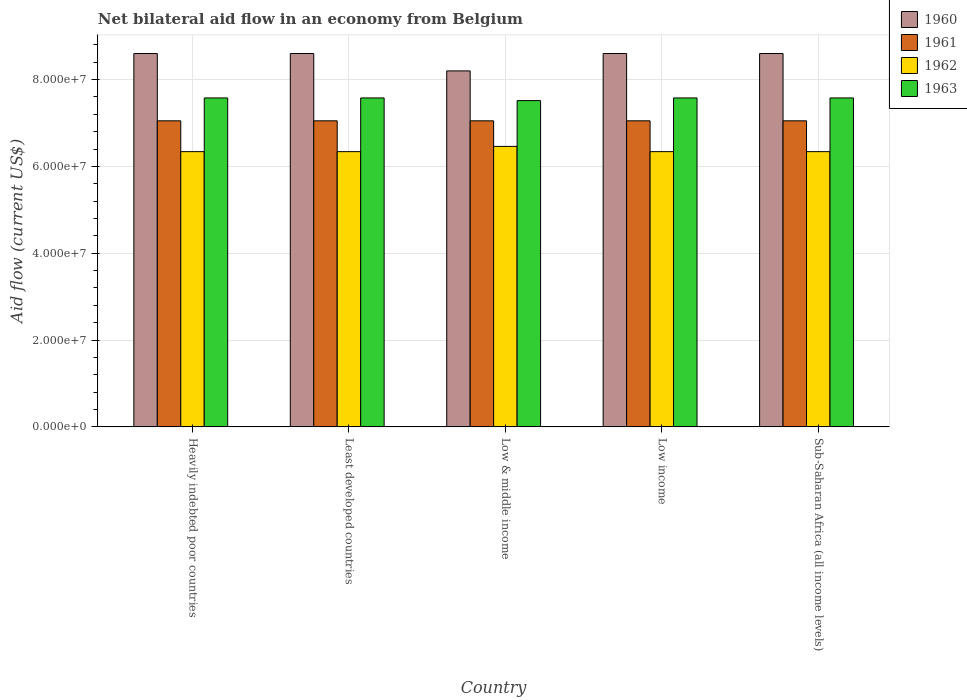How many groups of bars are there?
Keep it short and to the point. 5. Are the number of bars per tick equal to the number of legend labels?
Provide a succinct answer. Yes. How many bars are there on the 3rd tick from the left?
Make the answer very short. 4. How many bars are there on the 1st tick from the right?
Your answer should be very brief. 4. What is the label of the 5th group of bars from the left?
Provide a succinct answer. Sub-Saharan Africa (all income levels). In how many cases, is the number of bars for a given country not equal to the number of legend labels?
Offer a terse response. 0. What is the net bilateral aid flow in 1960 in Low & middle income?
Provide a succinct answer. 8.20e+07. Across all countries, what is the maximum net bilateral aid flow in 1960?
Ensure brevity in your answer.  8.60e+07. Across all countries, what is the minimum net bilateral aid flow in 1961?
Your answer should be compact. 7.05e+07. In which country was the net bilateral aid flow in 1963 maximum?
Offer a terse response. Heavily indebted poor countries. In which country was the net bilateral aid flow in 1962 minimum?
Make the answer very short. Heavily indebted poor countries. What is the total net bilateral aid flow in 1960 in the graph?
Your answer should be very brief. 4.26e+08. What is the difference between the net bilateral aid flow in 1963 in Sub-Saharan Africa (all income levels) and the net bilateral aid flow in 1962 in Least developed countries?
Provide a short and direct response. 1.24e+07. What is the average net bilateral aid flow in 1963 per country?
Your answer should be compact. 7.56e+07. What is the difference between the net bilateral aid flow of/in 1962 and net bilateral aid flow of/in 1960 in Low & middle income?
Keep it short and to the point. -1.74e+07. In how many countries, is the net bilateral aid flow in 1960 greater than 36000000 US$?
Offer a very short reply. 5. What is the ratio of the net bilateral aid flow in 1963 in Low income to that in Sub-Saharan Africa (all income levels)?
Your answer should be very brief. 1. Is the difference between the net bilateral aid flow in 1962 in Heavily indebted poor countries and Sub-Saharan Africa (all income levels) greater than the difference between the net bilateral aid flow in 1960 in Heavily indebted poor countries and Sub-Saharan Africa (all income levels)?
Offer a very short reply. No. What is the difference between the highest and the second highest net bilateral aid flow in 1962?
Ensure brevity in your answer.  1.21e+06. What is the difference between the highest and the lowest net bilateral aid flow in 1961?
Your response must be concise. 0. Is the sum of the net bilateral aid flow in 1963 in Heavily indebted poor countries and Low income greater than the maximum net bilateral aid flow in 1960 across all countries?
Make the answer very short. Yes. Is it the case that in every country, the sum of the net bilateral aid flow in 1960 and net bilateral aid flow in 1963 is greater than the sum of net bilateral aid flow in 1961 and net bilateral aid flow in 1962?
Provide a short and direct response. No. What is the difference between two consecutive major ticks on the Y-axis?
Your answer should be very brief. 2.00e+07. Are the values on the major ticks of Y-axis written in scientific E-notation?
Your response must be concise. Yes. Does the graph contain grids?
Make the answer very short. Yes. Where does the legend appear in the graph?
Give a very brief answer. Top right. How many legend labels are there?
Your answer should be compact. 4. How are the legend labels stacked?
Offer a very short reply. Vertical. What is the title of the graph?
Ensure brevity in your answer.  Net bilateral aid flow in an economy from Belgium. Does "2011" appear as one of the legend labels in the graph?
Your response must be concise. No. What is the label or title of the Y-axis?
Your answer should be compact. Aid flow (current US$). What is the Aid flow (current US$) in 1960 in Heavily indebted poor countries?
Ensure brevity in your answer.  8.60e+07. What is the Aid flow (current US$) of 1961 in Heavily indebted poor countries?
Your answer should be very brief. 7.05e+07. What is the Aid flow (current US$) of 1962 in Heavily indebted poor countries?
Offer a terse response. 6.34e+07. What is the Aid flow (current US$) in 1963 in Heavily indebted poor countries?
Offer a very short reply. 7.58e+07. What is the Aid flow (current US$) of 1960 in Least developed countries?
Your response must be concise. 8.60e+07. What is the Aid flow (current US$) of 1961 in Least developed countries?
Provide a short and direct response. 7.05e+07. What is the Aid flow (current US$) in 1962 in Least developed countries?
Keep it short and to the point. 6.34e+07. What is the Aid flow (current US$) in 1963 in Least developed countries?
Offer a very short reply. 7.58e+07. What is the Aid flow (current US$) in 1960 in Low & middle income?
Offer a very short reply. 8.20e+07. What is the Aid flow (current US$) of 1961 in Low & middle income?
Provide a short and direct response. 7.05e+07. What is the Aid flow (current US$) in 1962 in Low & middle income?
Your answer should be compact. 6.46e+07. What is the Aid flow (current US$) in 1963 in Low & middle income?
Provide a short and direct response. 7.52e+07. What is the Aid flow (current US$) of 1960 in Low income?
Your answer should be very brief. 8.60e+07. What is the Aid flow (current US$) of 1961 in Low income?
Give a very brief answer. 7.05e+07. What is the Aid flow (current US$) in 1962 in Low income?
Keep it short and to the point. 6.34e+07. What is the Aid flow (current US$) of 1963 in Low income?
Provide a short and direct response. 7.58e+07. What is the Aid flow (current US$) of 1960 in Sub-Saharan Africa (all income levels)?
Your answer should be compact. 8.60e+07. What is the Aid flow (current US$) in 1961 in Sub-Saharan Africa (all income levels)?
Offer a very short reply. 7.05e+07. What is the Aid flow (current US$) in 1962 in Sub-Saharan Africa (all income levels)?
Offer a terse response. 6.34e+07. What is the Aid flow (current US$) of 1963 in Sub-Saharan Africa (all income levels)?
Give a very brief answer. 7.58e+07. Across all countries, what is the maximum Aid flow (current US$) in 1960?
Ensure brevity in your answer.  8.60e+07. Across all countries, what is the maximum Aid flow (current US$) of 1961?
Provide a succinct answer. 7.05e+07. Across all countries, what is the maximum Aid flow (current US$) of 1962?
Ensure brevity in your answer.  6.46e+07. Across all countries, what is the maximum Aid flow (current US$) in 1963?
Your answer should be very brief. 7.58e+07. Across all countries, what is the minimum Aid flow (current US$) in 1960?
Make the answer very short. 8.20e+07. Across all countries, what is the minimum Aid flow (current US$) of 1961?
Provide a succinct answer. 7.05e+07. Across all countries, what is the minimum Aid flow (current US$) of 1962?
Make the answer very short. 6.34e+07. Across all countries, what is the minimum Aid flow (current US$) of 1963?
Keep it short and to the point. 7.52e+07. What is the total Aid flow (current US$) in 1960 in the graph?
Give a very brief answer. 4.26e+08. What is the total Aid flow (current US$) in 1961 in the graph?
Make the answer very short. 3.52e+08. What is the total Aid flow (current US$) in 1962 in the graph?
Your answer should be compact. 3.18e+08. What is the total Aid flow (current US$) in 1963 in the graph?
Ensure brevity in your answer.  3.78e+08. What is the difference between the Aid flow (current US$) of 1961 in Heavily indebted poor countries and that in Low & middle income?
Your response must be concise. 0. What is the difference between the Aid flow (current US$) in 1962 in Heavily indebted poor countries and that in Low & middle income?
Ensure brevity in your answer.  -1.21e+06. What is the difference between the Aid flow (current US$) of 1963 in Heavily indebted poor countries and that in Low & middle income?
Offer a terse response. 6.10e+05. What is the difference between the Aid flow (current US$) in 1960 in Heavily indebted poor countries and that in Low income?
Make the answer very short. 0. What is the difference between the Aid flow (current US$) in 1961 in Heavily indebted poor countries and that in Low income?
Give a very brief answer. 0. What is the difference between the Aid flow (current US$) of 1963 in Heavily indebted poor countries and that in Low income?
Your answer should be very brief. 0. What is the difference between the Aid flow (current US$) in 1961 in Heavily indebted poor countries and that in Sub-Saharan Africa (all income levels)?
Your answer should be very brief. 0. What is the difference between the Aid flow (current US$) in 1962 in Heavily indebted poor countries and that in Sub-Saharan Africa (all income levels)?
Ensure brevity in your answer.  0. What is the difference between the Aid flow (current US$) in 1963 in Heavily indebted poor countries and that in Sub-Saharan Africa (all income levels)?
Give a very brief answer. 0. What is the difference between the Aid flow (current US$) in 1961 in Least developed countries and that in Low & middle income?
Offer a very short reply. 0. What is the difference between the Aid flow (current US$) of 1962 in Least developed countries and that in Low & middle income?
Offer a very short reply. -1.21e+06. What is the difference between the Aid flow (current US$) in 1963 in Least developed countries and that in Low & middle income?
Your response must be concise. 6.10e+05. What is the difference between the Aid flow (current US$) in 1960 in Least developed countries and that in Low income?
Provide a succinct answer. 0. What is the difference between the Aid flow (current US$) of 1962 in Least developed countries and that in Low income?
Offer a terse response. 0. What is the difference between the Aid flow (current US$) in 1960 in Least developed countries and that in Sub-Saharan Africa (all income levels)?
Your answer should be very brief. 0. What is the difference between the Aid flow (current US$) of 1962 in Least developed countries and that in Sub-Saharan Africa (all income levels)?
Offer a terse response. 0. What is the difference between the Aid flow (current US$) of 1963 in Least developed countries and that in Sub-Saharan Africa (all income levels)?
Keep it short and to the point. 0. What is the difference between the Aid flow (current US$) of 1962 in Low & middle income and that in Low income?
Ensure brevity in your answer.  1.21e+06. What is the difference between the Aid flow (current US$) in 1963 in Low & middle income and that in Low income?
Ensure brevity in your answer.  -6.10e+05. What is the difference between the Aid flow (current US$) in 1961 in Low & middle income and that in Sub-Saharan Africa (all income levels)?
Give a very brief answer. 0. What is the difference between the Aid flow (current US$) in 1962 in Low & middle income and that in Sub-Saharan Africa (all income levels)?
Provide a succinct answer. 1.21e+06. What is the difference between the Aid flow (current US$) in 1963 in Low & middle income and that in Sub-Saharan Africa (all income levels)?
Your answer should be compact. -6.10e+05. What is the difference between the Aid flow (current US$) in 1963 in Low income and that in Sub-Saharan Africa (all income levels)?
Ensure brevity in your answer.  0. What is the difference between the Aid flow (current US$) of 1960 in Heavily indebted poor countries and the Aid flow (current US$) of 1961 in Least developed countries?
Offer a very short reply. 1.55e+07. What is the difference between the Aid flow (current US$) in 1960 in Heavily indebted poor countries and the Aid flow (current US$) in 1962 in Least developed countries?
Your answer should be very brief. 2.26e+07. What is the difference between the Aid flow (current US$) in 1960 in Heavily indebted poor countries and the Aid flow (current US$) in 1963 in Least developed countries?
Make the answer very short. 1.02e+07. What is the difference between the Aid flow (current US$) in 1961 in Heavily indebted poor countries and the Aid flow (current US$) in 1962 in Least developed countries?
Offer a terse response. 7.10e+06. What is the difference between the Aid flow (current US$) in 1961 in Heavily indebted poor countries and the Aid flow (current US$) in 1963 in Least developed countries?
Give a very brief answer. -5.27e+06. What is the difference between the Aid flow (current US$) in 1962 in Heavily indebted poor countries and the Aid flow (current US$) in 1963 in Least developed countries?
Ensure brevity in your answer.  -1.24e+07. What is the difference between the Aid flow (current US$) in 1960 in Heavily indebted poor countries and the Aid flow (current US$) in 1961 in Low & middle income?
Offer a very short reply. 1.55e+07. What is the difference between the Aid flow (current US$) of 1960 in Heavily indebted poor countries and the Aid flow (current US$) of 1962 in Low & middle income?
Ensure brevity in your answer.  2.14e+07. What is the difference between the Aid flow (current US$) of 1960 in Heavily indebted poor countries and the Aid flow (current US$) of 1963 in Low & middle income?
Keep it short and to the point. 1.08e+07. What is the difference between the Aid flow (current US$) of 1961 in Heavily indebted poor countries and the Aid flow (current US$) of 1962 in Low & middle income?
Offer a very short reply. 5.89e+06. What is the difference between the Aid flow (current US$) of 1961 in Heavily indebted poor countries and the Aid flow (current US$) of 1963 in Low & middle income?
Your response must be concise. -4.66e+06. What is the difference between the Aid flow (current US$) in 1962 in Heavily indebted poor countries and the Aid flow (current US$) in 1963 in Low & middle income?
Your answer should be very brief. -1.18e+07. What is the difference between the Aid flow (current US$) of 1960 in Heavily indebted poor countries and the Aid flow (current US$) of 1961 in Low income?
Offer a terse response. 1.55e+07. What is the difference between the Aid flow (current US$) of 1960 in Heavily indebted poor countries and the Aid flow (current US$) of 1962 in Low income?
Offer a very short reply. 2.26e+07. What is the difference between the Aid flow (current US$) of 1960 in Heavily indebted poor countries and the Aid flow (current US$) of 1963 in Low income?
Offer a terse response. 1.02e+07. What is the difference between the Aid flow (current US$) of 1961 in Heavily indebted poor countries and the Aid flow (current US$) of 1962 in Low income?
Keep it short and to the point. 7.10e+06. What is the difference between the Aid flow (current US$) in 1961 in Heavily indebted poor countries and the Aid flow (current US$) in 1963 in Low income?
Ensure brevity in your answer.  -5.27e+06. What is the difference between the Aid flow (current US$) of 1962 in Heavily indebted poor countries and the Aid flow (current US$) of 1963 in Low income?
Offer a very short reply. -1.24e+07. What is the difference between the Aid flow (current US$) of 1960 in Heavily indebted poor countries and the Aid flow (current US$) of 1961 in Sub-Saharan Africa (all income levels)?
Provide a succinct answer. 1.55e+07. What is the difference between the Aid flow (current US$) in 1960 in Heavily indebted poor countries and the Aid flow (current US$) in 1962 in Sub-Saharan Africa (all income levels)?
Provide a succinct answer. 2.26e+07. What is the difference between the Aid flow (current US$) in 1960 in Heavily indebted poor countries and the Aid flow (current US$) in 1963 in Sub-Saharan Africa (all income levels)?
Give a very brief answer. 1.02e+07. What is the difference between the Aid flow (current US$) in 1961 in Heavily indebted poor countries and the Aid flow (current US$) in 1962 in Sub-Saharan Africa (all income levels)?
Give a very brief answer. 7.10e+06. What is the difference between the Aid flow (current US$) in 1961 in Heavily indebted poor countries and the Aid flow (current US$) in 1963 in Sub-Saharan Africa (all income levels)?
Make the answer very short. -5.27e+06. What is the difference between the Aid flow (current US$) in 1962 in Heavily indebted poor countries and the Aid flow (current US$) in 1963 in Sub-Saharan Africa (all income levels)?
Offer a very short reply. -1.24e+07. What is the difference between the Aid flow (current US$) of 1960 in Least developed countries and the Aid flow (current US$) of 1961 in Low & middle income?
Keep it short and to the point. 1.55e+07. What is the difference between the Aid flow (current US$) in 1960 in Least developed countries and the Aid flow (current US$) in 1962 in Low & middle income?
Your response must be concise. 2.14e+07. What is the difference between the Aid flow (current US$) in 1960 in Least developed countries and the Aid flow (current US$) in 1963 in Low & middle income?
Give a very brief answer. 1.08e+07. What is the difference between the Aid flow (current US$) of 1961 in Least developed countries and the Aid flow (current US$) of 1962 in Low & middle income?
Ensure brevity in your answer.  5.89e+06. What is the difference between the Aid flow (current US$) in 1961 in Least developed countries and the Aid flow (current US$) in 1963 in Low & middle income?
Keep it short and to the point. -4.66e+06. What is the difference between the Aid flow (current US$) in 1962 in Least developed countries and the Aid flow (current US$) in 1963 in Low & middle income?
Your answer should be compact. -1.18e+07. What is the difference between the Aid flow (current US$) of 1960 in Least developed countries and the Aid flow (current US$) of 1961 in Low income?
Provide a short and direct response. 1.55e+07. What is the difference between the Aid flow (current US$) of 1960 in Least developed countries and the Aid flow (current US$) of 1962 in Low income?
Offer a very short reply. 2.26e+07. What is the difference between the Aid flow (current US$) of 1960 in Least developed countries and the Aid flow (current US$) of 1963 in Low income?
Ensure brevity in your answer.  1.02e+07. What is the difference between the Aid flow (current US$) of 1961 in Least developed countries and the Aid flow (current US$) of 1962 in Low income?
Give a very brief answer. 7.10e+06. What is the difference between the Aid flow (current US$) in 1961 in Least developed countries and the Aid flow (current US$) in 1963 in Low income?
Offer a very short reply. -5.27e+06. What is the difference between the Aid flow (current US$) of 1962 in Least developed countries and the Aid flow (current US$) of 1963 in Low income?
Ensure brevity in your answer.  -1.24e+07. What is the difference between the Aid flow (current US$) of 1960 in Least developed countries and the Aid flow (current US$) of 1961 in Sub-Saharan Africa (all income levels)?
Your response must be concise. 1.55e+07. What is the difference between the Aid flow (current US$) of 1960 in Least developed countries and the Aid flow (current US$) of 1962 in Sub-Saharan Africa (all income levels)?
Make the answer very short. 2.26e+07. What is the difference between the Aid flow (current US$) in 1960 in Least developed countries and the Aid flow (current US$) in 1963 in Sub-Saharan Africa (all income levels)?
Your answer should be very brief. 1.02e+07. What is the difference between the Aid flow (current US$) in 1961 in Least developed countries and the Aid flow (current US$) in 1962 in Sub-Saharan Africa (all income levels)?
Make the answer very short. 7.10e+06. What is the difference between the Aid flow (current US$) of 1961 in Least developed countries and the Aid flow (current US$) of 1963 in Sub-Saharan Africa (all income levels)?
Ensure brevity in your answer.  -5.27e+06. What is the difference between the Aid flow (current US$) of 1962 in Least developed countries and the Aid flow (current US$) of 1963 in Sub-Saharan Africa (all income levels)?
Offer a terse response. -1.24e+07. What is the difference between the Aid flow (current US$) in 1960 in Low & middle income and the Aid flow (current US$) in 1961 in Low income?
Offer a terse response. 1.15e+07. What is the difference between the Aid flow (current US$) in 1960 in Low & middle income and the Aid flow (current US$) in 1962 in Low income?
Provide a succinct answer. 1.86e+07. What is the difference between the Aid flow (current US$) of 1960 in Low & middle income and the Aid flow (current US$) of 1963 in Low income?
Ensure brevity in your answer.  6.23e+06. What is the difference between the Aid flow (current US$) of 1961 in Low & middle income and the Aid flow (current US$) of 1962 in Low income?
Offer a terse response. 7.10e+06. What is the difference between the Aid flow (current US$) in 1961 in Low & middle income and the Aid flow (current US$) in 1963 in Low income?
Keep it short and to the point. -5.27e+06. What is the difference between the Aid flow (current US$) in 1962 in Low & middle income and the Aid flow (current US$) in 1963 in Low income?
Make the answer very short. -1.12e+07. What is the difference between the Aid flow (current US$) in 1960 in Low & middle income and the Aid flow (current US$) in 1961 in Sub-Saharan Africa (all income levels)?
Provide a succinct answer. 1.15e+07. What is the difference between the Aid flow (current US$) in 1960 in Low & middle income and the Aid flow (current US$) in 1962 in Sub-Saharan Africa (all income levels)?
Offer a very short reply. 1.86e+07. What is the difference between the Aid flow (current US$) in 1960 in Low & middle income and the Aid flow (current US$) in 1963 in Sub-Saharan Africa (all income levels)?
Offer a terse response. 6.23e+06. What is the difference between the Aid flow (current US$) of 1961 in Low & middle income and the Aid flow (current US$) of 1962 in Sub-Saharan Africa (all income levels)?
Make the answer very short. 7.10e+06. What is the difference between the Aid flow (current US$) of 1961 in Low & middle income and the Aid flow (current US$) of 1963 in Sub-Saharan Africa (all income levels)?
Keep it short and to the point. -5.27e+06. What is the difference between the Aid flow (current US$) in 1962 in Low & middle income and the Aid flow (current US$) in 1963 in Sub-Saharan Africa (all income levels)?
Offer a terse response. -1.12e+07. What is the difference between the Aid flow (current US$) in 1960 in Low income and the Aid flow (current US$) in 1961 in Sub-Saharan Africa (all income levels)?
Provide a succinct answer. 1.55e+07. What is the difference between the Aid flow (current US$) of 1960 in Low income and the Aid flow (current US$) of 1962 in Sub-Saharan Africa (all income levels)?
Ensure brevity in your answer.  2.26e+07. What is the difference between the Aid flow (current US$) of 1960 in Low income and the Aid flow (current US$) of 1963 in Sub-Saharan Africa (all income levels)?
Make the answer very short. 1.02e+07. What is the difference between the Aid flow (current US$) of 1961 in Low income and the Aid flow (current US$) of 1962 in Sub-Saharan Africa (all income levels)?
Your answer should be very brief. 7.10e+06. What is the difference between the Aid flow (current US$) of 1961 in Low income and the Aid flow (current US$) of 1963 in Sub-Saharan Africa (all income levels)?
Give a very brief answer. -5.27e+06. What is the difference between the Aid flow (current US$) of 1962 in Low income and the Aid flow (current US$) of 1963 in Sub-Saharan Africa (all income levels)?
Offer a terse response. -1.24e+07. What is the average Aid flow (current US$) in 1960 per country?
Keep it short and to the point. 8.52e+07. What is the average Aid flow (current US$) in 1961 per country?
Provide a succinct answer. 7.05e+07. What is the average Aid flow (current US$) of 1962 per country?
Give a very brief answer. 6.36e+07. What is the average Aid flow (current US$) of 1963 per country?
Offer a terse response. 7.56e+07. What is the difference between the Aid flow (current US$) of 1960 and Aid flow (current US$) of 1961 in Heavily indebted poor countries?
Your response must be concise. 1.55e+07. What is the difference between the Aid flow (current US$) in 1960 and Aid flow (current US$) in 1962 in Heavily indebted poor countries?
Ensure brevity in your answer.  2.26e+07. What is the difference between the Aid flow (current US$) of 1960 and Aid flow (current US$) of 1963 in Heavily indebted poor countries?
Your answer should be compact. 1.02e+07. What is the difference between the Aid flow (current US$) in 1961 and Aid flow (current US$) in 1962 in Heavily indebted poor countries?
Give a very brief answer. 7.10e+06. What is the difference between the Aid flow (current US$) in 1961 and Aid flow (current US$) in 1963 in Heavily indebted poor countries?
Provide a short and direct response. -5.27e+06. What is the difference between the Aid flow (current US$) in 1962 and Aid flow (current US$) in 1963 in Heavily indebted poor countries?
Provide a short and direct response. -1.24e+07. What is the difference between the Aid flow (current US$) of 1960 and Aid flow (current US$) of 1961 in Least developed countries?
Offer a very short reply. 1.55e+07. What is the difference between the Aid flow (current US$) of 1960 and Aid flow (current US$) of 1962 in Least developed countries?
Provide a succinct answer. 2.26e+07. What is the difference between the Aid flow (current US$) in 1960 and Aid flow (current US$) in 1963 in Least developed countries?
Provide a succinct answer. 1.02e+07. What is the difference between the Aid flow (current US$) in 1961 and Aid flow (current US$) in 1962 in Least developed countries?
Provide a succinct answer. 7.10e+06. What is the difference between the Aid flow (current US$) in 1961 and Aid flow (current US$) in 1963 in Least developed countries?
Offer a very short reply. -5.27e+06. What is the difference between the Aid flow (current US$) of 1962 and Aid flow (current US$) of 1963 in Least developed countries?
Ensure brevity in your answer.  -1.24e+07. What is the difference between the Aid flow (current US$) of 1960 and Aid flow (current US$) of 1961 in Low & middle income?
Your response must be concise. 1.15e+07. What is the difference between the Aid flow (current US$) in 1960 and Aid flow (current US$) in 1962 in Low & middle income?
Your answer should be compact. 1.74e+07. What is the difference between the Aid flow (current US$) of 1960 and Aid flow (current US$) of 1963 in Low & middle income?
Provide a short and direct response. 6.84e+06. What is the difference between the Aid flow (current US$) of 1961 and Aid flow (current US$) of 1962 in Low & middle income?
Your response must be concise. 5.89e+06. What is the difference between the Aid flow (current US$) in 1961 and Aid flow (current US$) in 1963 in Low & middle income?
Make the answer very short. -4.66e+06. What is the difference between the Aid flow (current US$) in 1962 and Aid flow (current US$) in 1963 in Low & middle income?
Provide a succinct answer. -1.06e+07. What is the difference between the Aid flow (current US$) of 1960 and Aid flow (current US$) of 1961 in Low income?
Offer a very short reply. 1.55e+07. What is the difference between the Aid flow (current US$) in 1960 and Aid flow (current US$) in 1962 in Low income?
Ensure brevity in your answer.  2.26e+07. What is the difference between the Aid flow (current US$) in 1960 and Aid flow (current US$) in 1963 in Low income?
Provide a short and direct response. 1.02e+07. What is the difference between the Aid flow (current US$) in 1961 and Aid flow (current US$) in 1962 in Low income?
Your response must be concise. 7.10e+06. What is the difference between the Aid flow (current US$) of 1961 and Aid flow (current US$) of 1963 in Low income?
Keep it short and to the point. -5.27e+06. What is the difference between the Aid flow (current US$) in 1962 and Aid flow (current US$) in 1963 in Low income?
Your answer should be compact. -1.24e+07. What is the difference between the Aid flow (current US$) in 1960 and Aid flow (current US$) in 1961 in Sub-Saharan Africa (all income levels)?
Make the answer very short. 1.55e+07. What is the difference between the Aid flow (current US$) in 1960 and Aid flow (current US$) in 1962 in Sub-Saharan Africa (all income levels)?
Give a very brief answer. 2.26e+07. What is the difference between the Aid flow (current US$) of 1960 and Aid flow (current US$) of 1963 in Sub-Saharan Africa (all income levels)?
Your answer should be very brief. 1.02e+07. What is the difference between the Aid flow (current US$) of 1961 and Aid flow (current US$) of 1962 in Sub-Saharan Africa (all income levels)?
Your response must be concise. 7.10e+06. What is the difference between the Aid flow (current US$) in 1961 and Aid flow (current US$) in 1963 in Sub-Saharan Africa (all income levels)?
Give a very brief answer. -5.27e+06. What is the difference between the Aid flow (current US$) of 1962 and Aid flow (current US$) of 1963 in Sub-Saharan Africa (all income levels)?
Your answer should be compact. -1.24e+07. What is the ratio of the Aid flow (current US$) of 1960 in Heavily indebted poor countries to that in Least developed countries?
Offer a very short reply. 1. What is the ratio of the Aid flow (current US$) of 1961 in Heavily indebted poor countries to that in Least developed countries?
Your response must be concise. 1. What is the ratio of the Aid flow (current US$) in 1962 in Heavily indebted poor countries to that in Least developed countries?
Offer a very short reply. 1. What is the ratio of the Aid flow (current US$) in 1963 in Heavily indebted poor countries to that in Least developed countries?
Offer a very short reply. 1. What is the ratio of the Aid flow (current US$) of 1960 in Heavily indebted poor countries to that in Low & middle income?
Offer a very short reply. 1.05. What is the ratio of the Aid flow (current US$) in 1962 in Heavily indebted poor countries to that in Low & middle income?
Offer a terse response. 0.98. What is the ratio of the Aid flow (current US$) of 1961 in Heavily indebted poor countries to that in Low income?
Provide a succinct answer. 1. What is the ratio of the Aid flow (current US$) of 1963 in Heavily indebted poor countries to that in Low income?
Offer a terse response. 1. What is the ratio of the Aid flow (current US$) in 1960 in Heavily indebted poor countries to that in Sub-Saharan Africa (all income levels)?
Your response must be concise. 1. What is the ratio of the Aid flow (current US$) of 1962 in Heavily indebted poor countries to that in Sub-Saharan Africa (all income levels)?
Keep it short and to the point. 1. What is the ratio of the Aid flow (current US$) in 1963 in Heavily indebted poor countries to that in Sub-Saharan Africa (all income levels)?
Your response must be concise. 1. What is the ratio of the Aid flow (current US$) of 1960 in Least developed countries to that in Low & middle income?
Provide a succinct answer. 1.05. What is the ratio of the Aid flow (current US$) of 1962 in Least developed countries to that in Low & middle income?
Make the answer very short. 0.98. What is the ratio of the Aid flow (current US$) in 1963 in Least developed countries to that in Low & middle income?
Provide a short and direct response. 1.01. What is the ratio of the Aid flow (current US$) of 1960 in Least developed countries to that in Low income?
Ensure brevity in your answer.  1. What is the ratio of the Aid flow (current US$) of 1962 in Least developed countries to that in Low income?
Offer a terse response. 1. What is the ratio of the Aid flow (current US$) in 1963 in Least developed countries to that in Low income?
Your answer should be very brief. 1. What is the ratio of the Aid flow (current US$) in 1960 in Least developed countries to that in Sub-Saharan Africa (all income levels)?
Your response must be concise. 1. What is the ratio of the Aid flow (current US$) of 1961 in Least developed countries to that in Sub-Saharan Africa (all income levels)?
Provide a short and direct response. 1. What is the ratio of the Aid flow (current US$) in 1963 in Least developed countries to that in Sub-Saharan Africa (all income levels)?
Offer a terse response. 1. What is the ratio of the Aid flow (current US$) in 1960 in Low & middle income to that in Low income?
Your response must be concise. 0.95. What is the ratio of the Aid flow (current US$) in 1961 in Low & middle income to that in Low income?
Provide a succinct answer. 1. What is the ratio of the Aid flow (current US$) of 1962 in Low & middle income to that in Low income?
Give a very brief answer. 1.02. What is the ratio of the Aid flow (current US$) of 1960 in Low & middle income to that in Sub-Saharan Africa (all income levels)?
Your answer should be compact. 0.95. What is the ratio of the Aid flow (current US$) in 1961 in Low & middle income to that in Sub-Saharan Africa (all income levels)?
Provide a succinct answer. 1. What is the ratio of the Aid flow (current US$) of 1962 in Low & middle income to that in Sub-Saharan Africa (all income levels)?
Provide a succinct answer. 1.02. What is the ratio of the Aid flow (current US$) of 1963 in Low & middle income to that in Sub-Saharan Africa (all income levels)?
Provide a short and direct response. 0.99. What is the ratio of the Aid flow (current US$) in 1961 in Low income to that in Sub-Saharan Africa (all income levels)?
Your response must be concise. 1. What is the ratio of the Aid flow (current US$) of 1963 in Low income to that in Sub-Saharan Africa (all income levels)?
Offer a terse response. 1. What is the difference between the highest and the second highest Aid flow (current US$) of 1961?
Your answer should be compact. 0. What is the difference between the highest and the second highest Aid flow (current US$) of 1962?
Your answer should be compact. 1.21e+06. What is the difference between the highest and the lowest Aid flow (current US$) in 1961?
Offer a very short reply. 0. What is the difference between the highest and the lowest Aid flow (current US$) of 1962?
Make the answer very short. 1.21e+06. 